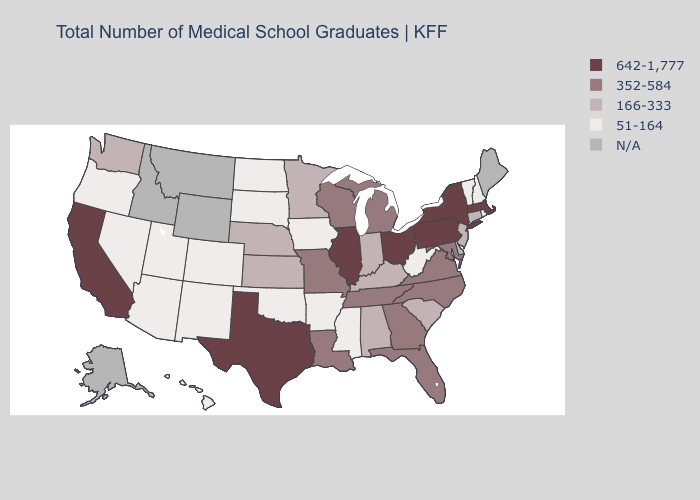Which states have the lowest value in the South?
Answer briefly. Arkansas, Mississippi, Oklahoma, West Virginia. What is the highest value in states that border Maine?
Answer briefly. 51-164. Name the states that have a value in the range N/A?
Give a very brief answer. Alaska, Delaware, Idaho, Maine, Montana, Wyoming. Among the states that border Georgia , which have the lowest value?
Be succinct. Alabama, South Carolina. Name the states that have a value in the range 352-584?
Give a very brief answer. Florida, Georgia, Louisiana, Maryland, Michigan, Missouri, North Carolina, Tennessee, Virginia, Wisconsin. Does the first symbol in the legend represent the smallest category?
Short answer required. No. How many symbols are there in the legend?
Short answer required. 5. Name the states that have a value in the range 352-584?
Be succinct. Florida, Georgia, Louisiana, Maryland, Michigan, Missouri, North Carolina, Tennessee, Virginia, Wisconsin. Name the states that have a value in the range 642-1,777?
Quick response, please. California, Illinois, Massachusetts, New York, Ohio, Pennsylvania, Texas. What is the value of North Carolina?
Write a very short answer. 352-584. What is the value of Tennessee?
Be succinct. 352-584. Name the states that have a value in the range 166-333?
Write a very short answer. Alabama, Connecticut, Indiana, Kansas, Kentucky, Minnesota, Nebraska, New Jersey, South Carolina, Washington. What is the value of Hawaii?
Quick response, please. 51-164. Among the states that border Colorado , does Nebraska have the highest value?
Quick response, please. Yes. 